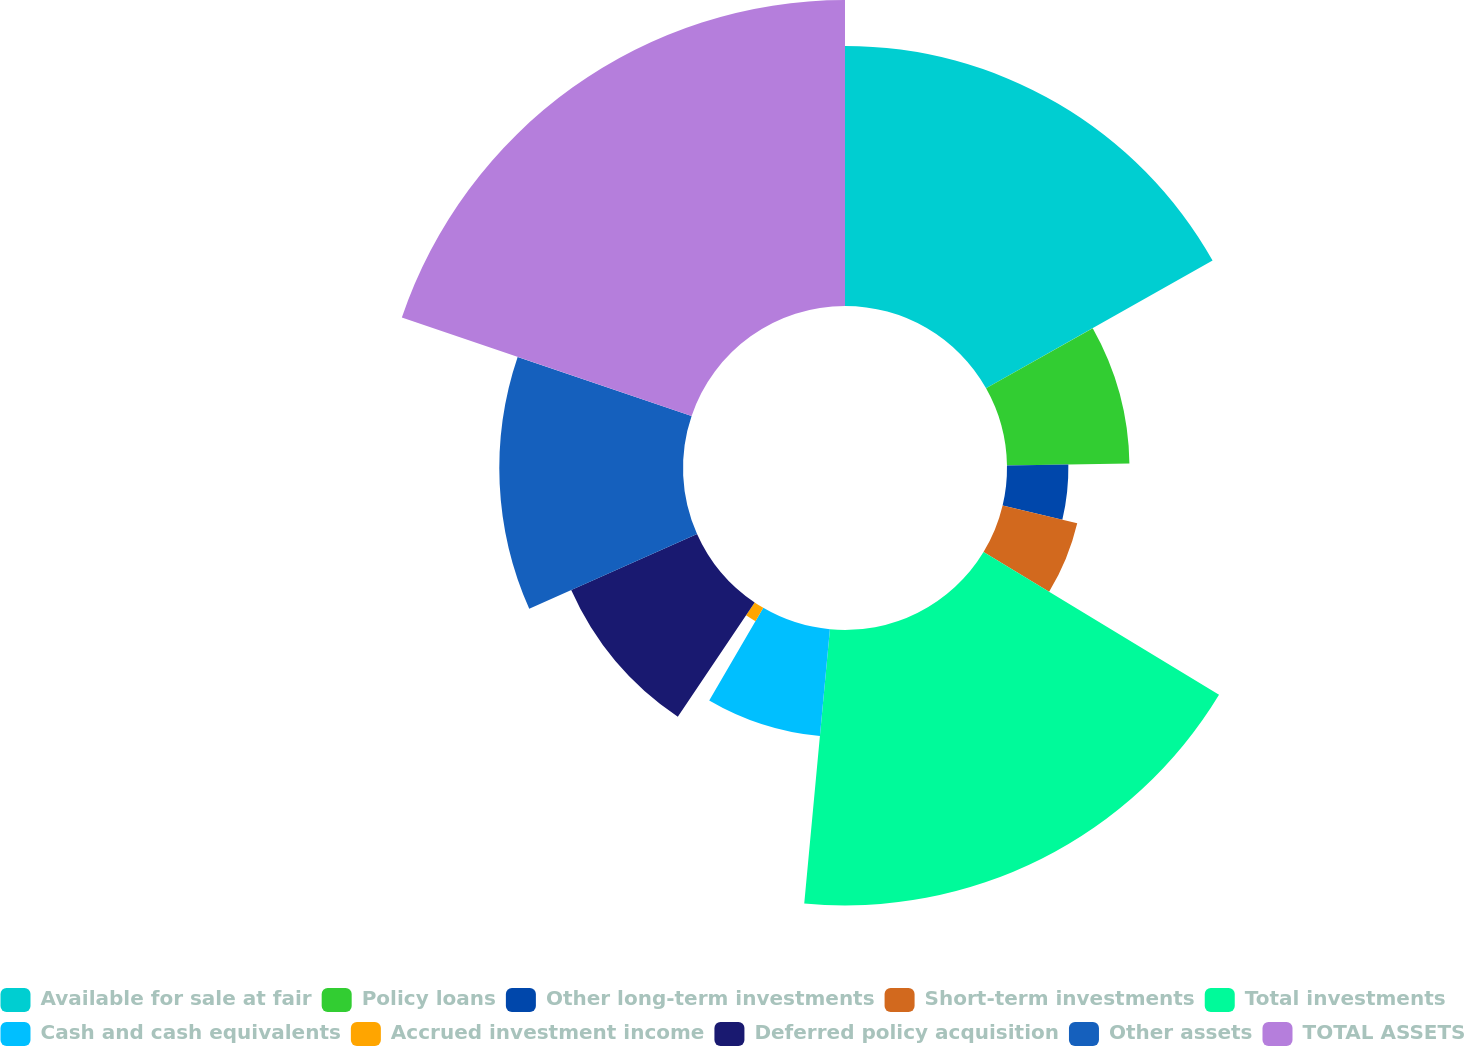Convert chart. <chart><loc_0><loc_0><loc_500><loc_500><pie_chart><fcel>Available for sale at fair<fcel>Policy loans<fcel>Other long-term investments<fcel>Short-term investments<fcel>Total investments<fcel>Cash and cash equivalents<fcel>Accrued investment income<fcel>Deferred policy acquisition<fcel>Other assets<fcel>TOTAL ASSETS<nl><fcel>16.82%<fcel>7.92%<fcel>3.97%<fcel>4.96%<fcel>17.81%<fcel>6.93%<fcel>1.0%<fcel>8.91%<fcel>11.88%<fcel>19.79%<nl></chart> 